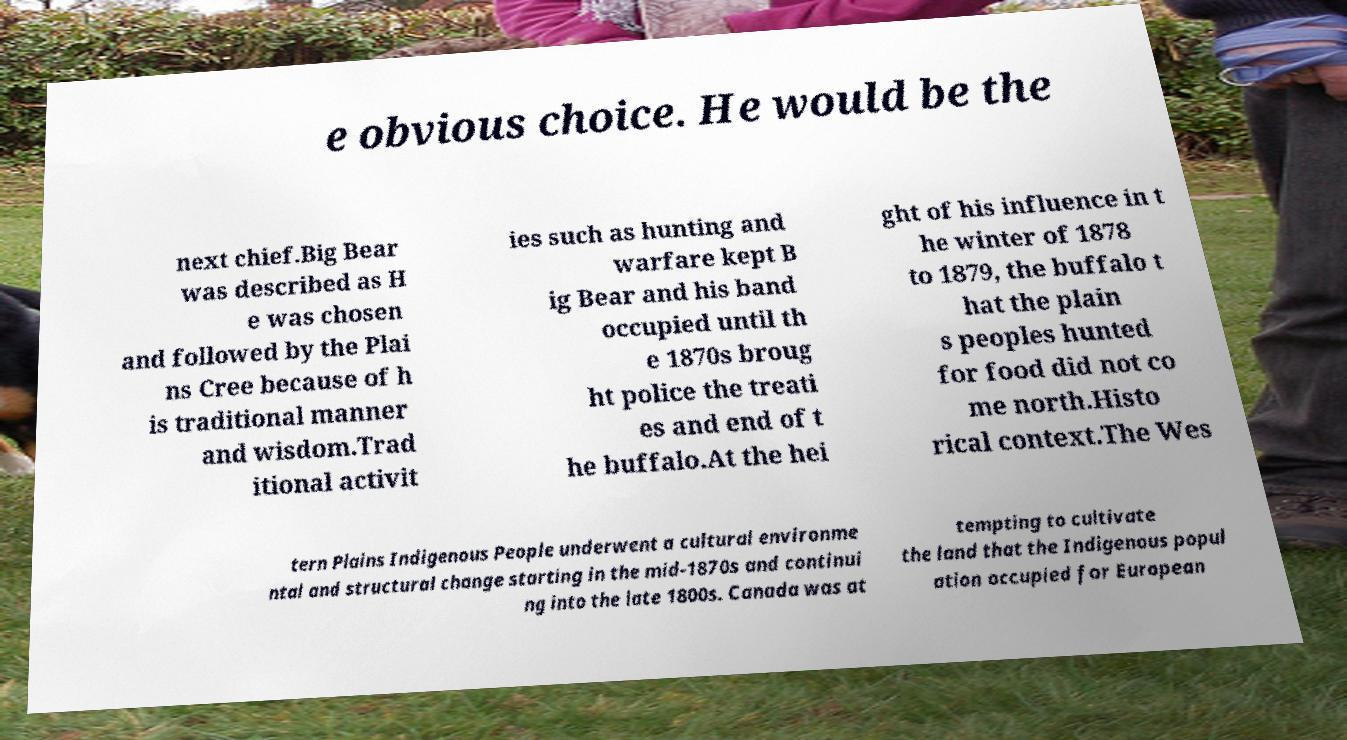Could you assist in decoding the text presented in this image and type it out clearly? e obvious choice. He would be the next chief.Big Bear was described as H e was chosen and followed by the Plai ns Cree because of h is traditional manner and wisdom.Trad itional activit ies such as hunting and warfare kept B ig Bear and his band occupied until th e 1870s broug ht police the treati es and end of t he buffalo.At the hei ght of his influence in t he winter of 1878 to 1879, the buffalo t hat the plain s peoples hunted for food did not co me north.Histo rical context.The Wes tern Plains Indigenous People underwent a cultural environme ntal and structural change starting in the mid-1870s and continui ng into the late 1800s. Canada was at tempting to cultivate the land that the Indigenous popul ation occupied for European 